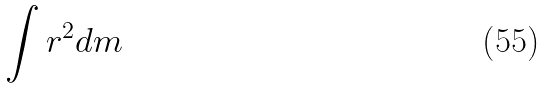Convert formula to latex. <formula><loc_0><loc_0><loc_500><loc_500>\int r ^ { 2 } d m</formula> 